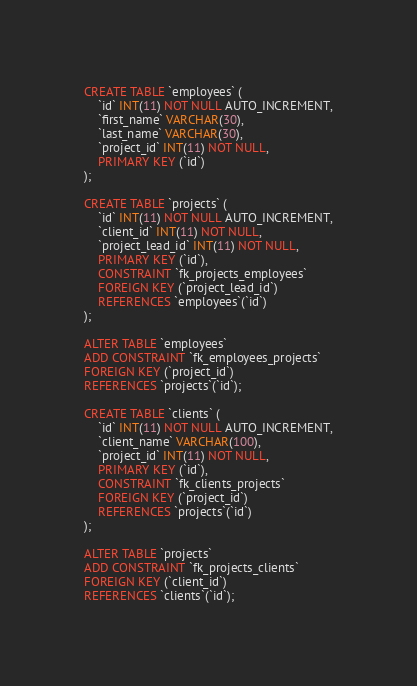Convert code to text. <code><loc_0><loc_0><loc_500><loc_500><_SQL_>CREATE TABLE `employees` (
	`id` INT(11) NOT NULL AUTO_INCREMENT,
    `first_name` VARCHAR(30),
    `last_name` VARCHAR(30),
    `project_id` INT(11) NOT NULL,
    PRIMARY KEY (`id`)
);

CREATE TABLE `projects` (
	`id` INT(11) NOT NULL AUTO_INCREMENT,
    `client_id` INT(11) NOT NULL,
    `project_lead_id` INT(11) NOT NULL,
    PRIMARY KEY (`id`),
    CONSTRAINT `fk_projects_employees`
    FOREIGN KEY (`project_lead_id`)
    REFERENCES `employees`(`id`)
);

ALTER TABLE `employees`
ADD CONSTRAINT `fk_employees_projects`
FOREIGN KEY (`project_id`)
REFERENCES `projects`(`id`);

CREATE TABLE `clients` (
	`id` INT(11) NOT NULL AUTO_INCREMENT,
    `client_name` VARCHAR(100),
    `project_id` INT(11) NOT NULL,
    PRIMARY KEY (`id`),
    CONSTRAINT `fk_clients_projects`
    FOREIGN KEY (`project_id`)
    REFERENCES `projects`(`id`)
);

ALTER TABLE `projects`
ADD CONSTRAINT `fk_projects_clients`
FOREIGN KEY (`client_id`)
REFERENCES `clients`(`id`);</code> 